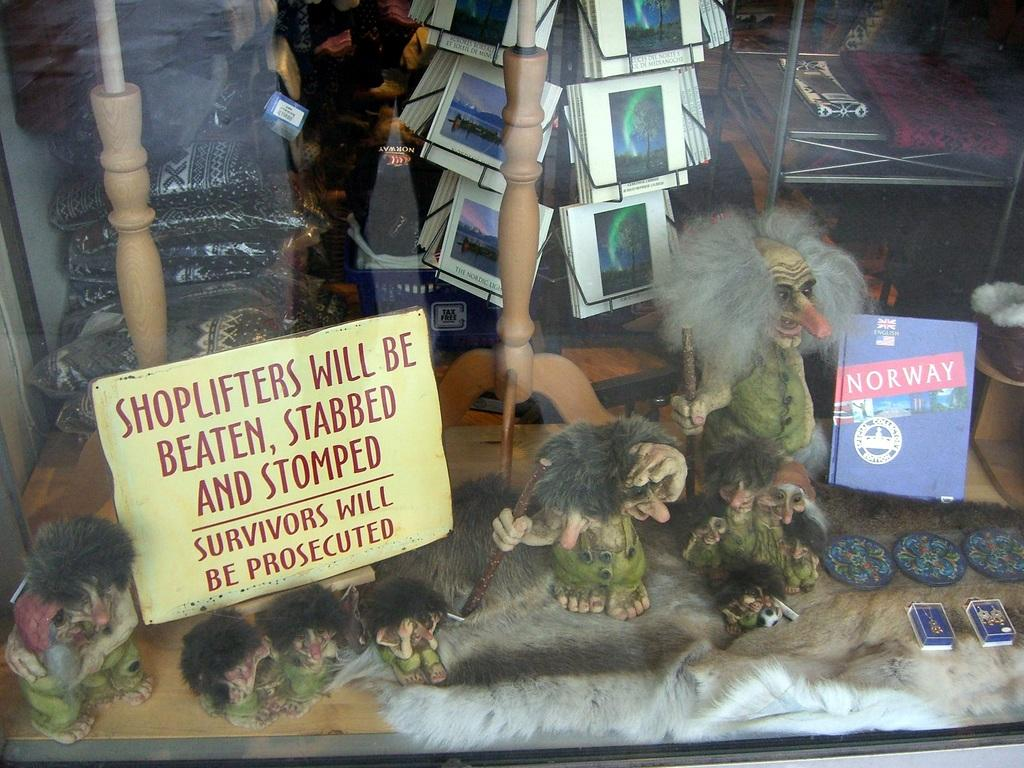<image>
Describe the image concisely. A store display with a sign stating that shoplifters will be beaten, stabbed, and stomped, and that survivors will be prosecuted. 